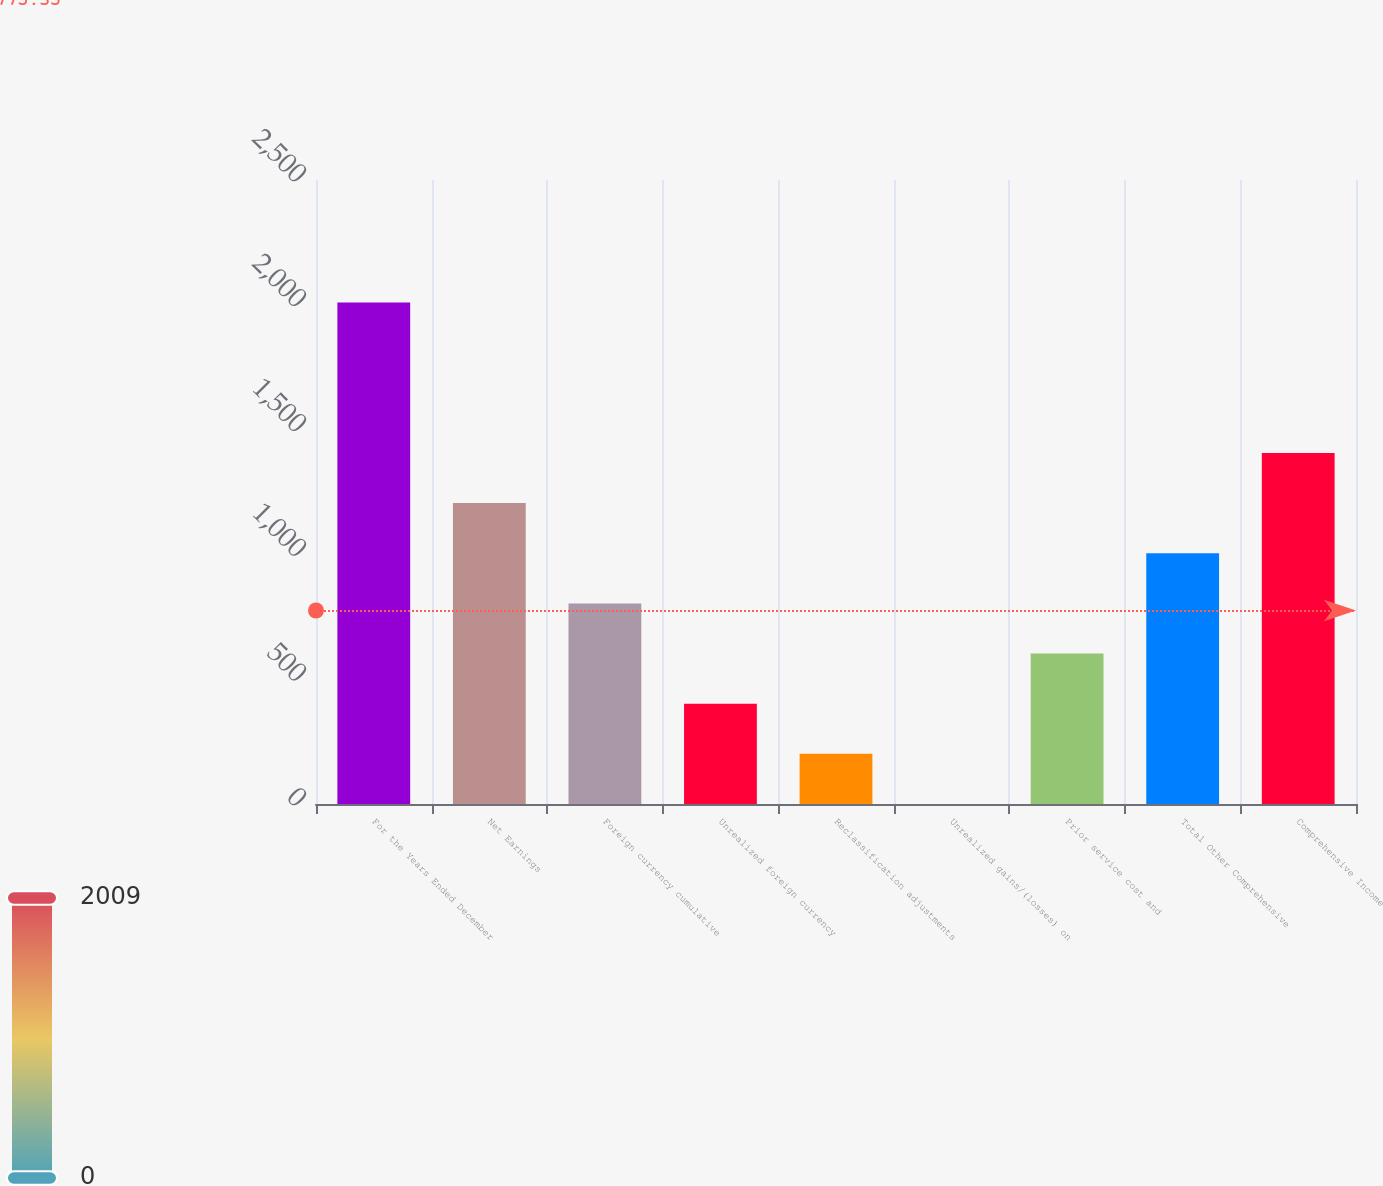Convert chart to OTSL. <chart><loc_0><loc_0><loc_500><loc_500><bar_chart><fcel>For the Years Ended December<fcel>Net Earnings<fcel>Foreign currency cumulative<fcel>Unrealized foreign currency<fcel>Reclassification adjustments<fcel>Unrealized gains/(losses) on<fcel>Prior service cost and<fcel>Total Other Comprehensive<fcel>Comprehensive Income<nl><fcel>2009<fcel>1205.52<fcel>803.78<fcel>402.04<fcel>201.17<fcel>0.3<fcel>602.91<fcel>1004.65<fcel>1406.39<nl></chart> 